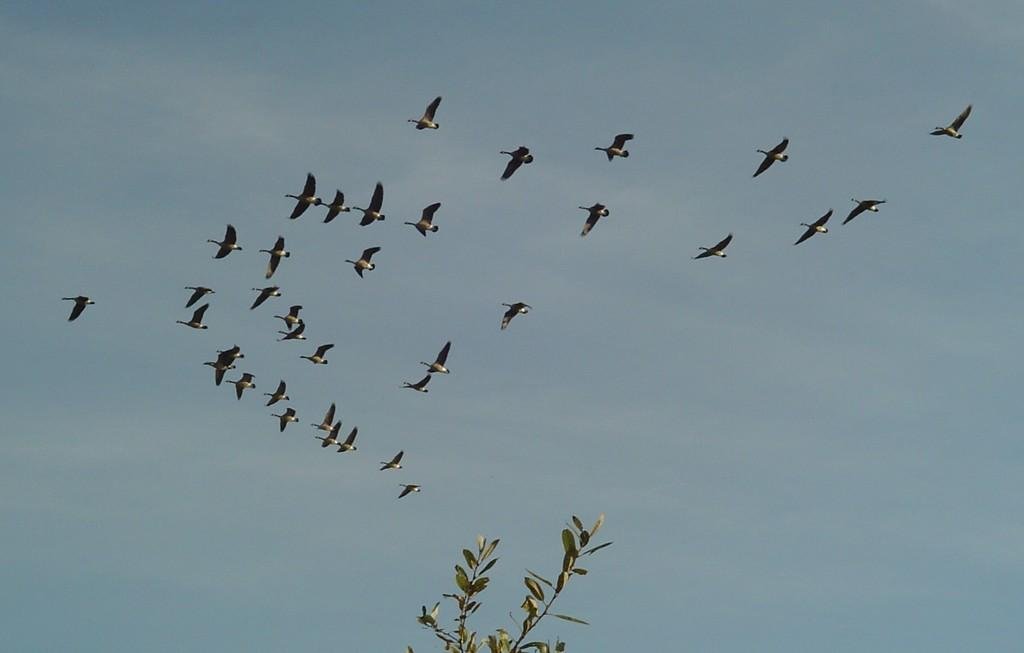What is happening with the birds in the image? There is a group of birds flying in the air. What can be seen at the bottom of the image? There is a plant at the bottom of the image. What is visible in the background of the image? The sky is visible in the background of the image. Where are the kittens playing in the image? There are no kittens present in the image. What is the front of the image showing? The provided facts do not mention a front or any specific direction in the image, so it cannot be determined from the information given. 